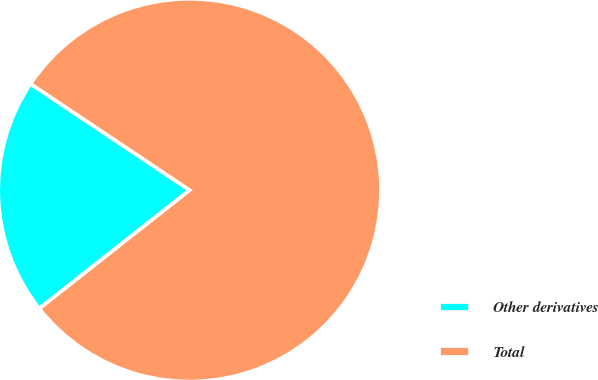<chart> <loc_0><loc_0><loc_500><loc_500><pie_chart><fcel>Other derivatives<fcel>Total<nl><fcel>20.0%<fcel>80.0%<nl></chart> 